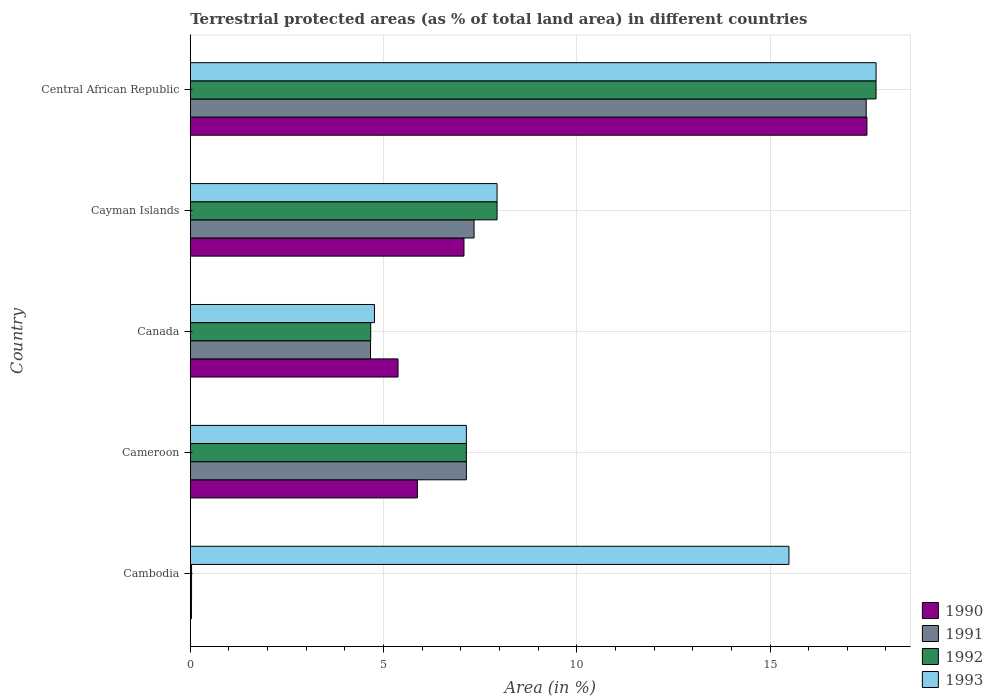How many groups of bars are there?
Ensure brevity in your answer.  5. What is the label of the 2nd group of bars from the top?
Provide a succinct answer. Cayman Islands. In how many cases, is the number of bars for a given country not equal to the number of legend labels?
Your answer should be compact. 0. What is the percentage of terrestrial protected land in 1993 in Cambodia?
Offer a terse response. 15.49. Across all countries, what is the maximum percentage of terrestrial protected land in 1993?
Keep it short and to the point. 17.74. Across all countries, what is the minimum percentage of terrestrial protected land in 1993?
Provide a short and direct response. 4.77. In which country was the percentage of terrestrial protected land in 1990 maximum?
Provide a short and direct response. Central African Republic. In which country was the percentage of terrestrial protected land in 1990 minimum?
Give a very brief answer. Cambodia. What is the total percentage of terrestrial protected land in 1993 in the graph?
Your answer should be very brief. 53.08. What is the difference between the percentage of terrestrial protected land in 1990 in Cameroon and that in Central African Republic?
Offer a very short reply. -11.63. What is the difference between the percentage of terrestrial protected land in 1991 in Central African Republic and the percentage of terrestrial protected land in 1992 in Canada?
Your answer should be very brief. 12.82. What is the average percentage of terrestrial protected land in 1990 per country?
Ensure brevity in your answer.  7.17. What is the difference between the percentage of terrestrial protected land in 1993 and percentage of terrestrial protected land in 1992 in Canada?
Offer a very short reply. 0.1. What is the ratio of the percentage of terrestrial protected land in 1990 in Cambodia to that in Cayman Islands?
Give a very brief answer. 0. Is the percentage of terrestrial protected land in 1991 in Cambodia less than that in Canada?
Give a very brief answer. Yes. What is the difference between the highest and the second highest percentage of terrestrial protected land in 1990?
Provide a short and direct response. 10.43. What is the difference between the highest and the lowest percentage of terrestrial protected land in 1992?
Your answer should be compact. 17.71. Is it the case that in every country, the sum of the percentage of terrestrial protected land in 1993 and percentage of terrestrial protected land in 1992 is greater than the sum of percentage of terrestrial protected land in 1991 and percentage of terrestrial protected land in 1990?
Give a very brief answer. Yes. What does the 1st bar from the top in Canada represents?
Keep it short and to the point. 1993. What does the 3rd bar from the bottom in Cameroon represents?
Your response must be concise. 1992. Are all the bars in the graph horizontal?
Your answer should be compact. Yes. How many countries are there in the graph?
Give a very brief answer. 5. What is the difference between two consecutive major ticks on the X-axis?
Provide a short and direct response. 5. Are the values on the major ticks of X-axis written in scientific E-notation?
Your response must be concise. No. Does the graph contain grids?
Your response must be concise. Yes. Where does the legend appear in the graph?
Your answer should be compact. Bottom right. What is the title of the graph?
Provide a succinct answer. Terrestrial protected areas (as % of total land area) in different countries. Does "1969" appear as one of the legend labels in the graph?
Provide a succinct answer. No. What is the label or title of the X-axis?
Provide a short and direct response. Area (in %). What is the Area (in %) of 1990 in Cambodia?
Keep it short and to the point. 0.03. What is the Area (in %) of 1991 in Cambodia?
Keep it short and to the point. 0.03. What is the Area (in %) of 1992 in Cambodia?
Ensure brevity in your answer.  0.03. What is the Area (in %) in 1993 in Cambodia?
Make the answer very short. 15.49. What is the Area (in %) of 1990 in Cameroon?
Keep it short and to the point. 5.88. What is the Area (in %) in 1991 in Cameroon?
Give a very brief answer. 7.14. What is the Area (in %) in 1992 in Cameroon?
Give a very brief answer. 7.14. What is the Area (in %) of 1993 in Cameroon?
Make the answer very short. 7.14. What is the Area (in %) of 1990 in Canada?
Your answer should be compact. 5.37. What is the Area (in %) of 1991 in Canada?
Your answer should be compact. 4.66. What is the Area (in %) in 1992 in Canada?
Ensure brevity in your answer.  4.67. What is the Area (in %) of 1993 in Canada?
Offer a very short reply. 4.77. What is the Area (in %) in 1990 in Cayman Islands?
Make the answer very short. 7.08. What is the Area (in %) of 1991 in Cayman Islands?
Your response must be concise. 7.34. What is the Area (in %) of 1992 in Cayman Islands?
Give a very brief answer. 7.94. What is the Area (in %) in 1993 in Cayman Islands?
Offer a terse response. 7.94. What is the Area (in %) in 1990 in Central African Republic?
Provide a succinct answer. 17.51. What is the Area (in %) of 1991 in Central African Republic?
Give a very brief answer. 17.49. What is the Area (in %) in 1992 in Central African Republic?
Provide a short and direct response. 17.74. What is the Area (in %) in 1993 in Central African Republic?
Make the answer very short. 17.74. Across all countries, what is the maximum Area (in %) of 1990?
Offer a terse response. 17.51. Across all countries, what is the maximum Area (in %) of 1991?
Provide a succinct answer. 17.49. Across all countries, what is the maximum Area (in %) of 1992?
Offer a very short reply. 17.74. Across all countries, what is the maximum Area (in %) in 1993?
Ensure brevity in your answer.  17.74. Across all countries, what is the minimum Area (in %) of 1990?
Give a very brief answer. 0.03. Across all countries, what is the minimum Area (in %) in 1991?
Your answer should be very brief. 0.03. Across all countries, what is the minimum Area (in %) of 1992?
Offer a very short reply. 0.03. Across all countries, what is the minimum Area (in %) of 1993?
Your answer should be very brief. 4.77. What is the total Area (in %) in 1990 in the graph?
Keep it short and to the point. 35.87. What is the total Area (in %) of 1991 in the graph?
Keep it short and to the point. 36.67. What is the total Area (in %) of 1992 in the graph?
Offer a very short reply. 37.53. What is the total Area (in %) in 1993 in the graph?
Your answer should be compact. 53.08. What is the difference between the Area (in %) in 1990 in Cambodia and that in Cameroon?
Keep it short and to the point. -5.85. What is the difference between the Area (in %) in 1991 in Cambodia and that in Cameroon?
Provide a short and direct response. -7.11. What is the difference between the Area (in %) of 1992 in Cambodia and that in Cameroon?
Your response must be concise. -7.11. What is the difference between the Area (in %) of 1993 in Cambodia and that in Cameroon?
Offer a terse response. 8.35. What is the difference between the Area (in %) of 1990 in Cambodia and that in Canada?
Your response must be concise. -5.35. What is the difference between the Area (in %) in 1991 in Cambodia and that in Canada?
Your answer should be compact. -4.63. What is the difference between the Area (in %) of 1992 in Cambodia and that in Canada?
Provide a succinct answer. -4.64. What is the difference between the Area (in %) of 1993 in Cambodia and that in Canada?
Offer a terse response. 10.72. What is the difference between the Area (in %) of 1990 in Cambodia and that in Cayman Islands?
Give a very brief answer. -7.05. What is the difference between the Area (in %) in 1991 in Cambodia and that in Cayman Islands?
Your response must be concise. -7.31. What is the difference between the Area (in %) of 1992 in Cambodia and that in Cayman Islands?
Your response must be concise. -7.9. What is the difference between the Area (in %) in 1993 in Cambodia and that in Cayman Islands?
Keep it short and to the point. 7.55. What is the difference between the Area (in %) of 1990 in Cambodia and that in Central African Republic?
Give a very brief answer. -17.48. What is the difference between the Area (in %) in 1991 in Cambodia and that in Central African Republic?
Give a very brief answer. -17.46. What is the difference between the Area (in %) of 1992 in Cambodia and that in Central African Republic?
Give a very brief answer. -17.71. What is the difference between the Area (in %) of 1993 in Cambodia and that in Central African Republic?
Provide a short and direct response. -2.25. What is the difference between the Area (in %) in 1990 in Cameroon and that in Canada?
Your answer should be compact. 0.5. What is the difference between the Area (in %) in 1991 in Cameroon and that in Canada?
Make the answer very short. 2.48. What is the difference between the Area (in %) in 1992 in Cameroon and that in Canada?
Your response must be concise. 2.48. What is the difference between the Area (in %) in 1993 in Cameroon and that in Canada?
Your response must be concise. 2.38. What is the difference between the Area (in %) of 1990 in Cameroon and that in Cayman Islands?
Offer a terse response. -1.21. What is the difference between the Area (in %) in 1991 in Cameroon and that in Cayman Islands?
Ensure brevity in your answer.  -0.2. What is the difference between the Area (in %) in 1992 in Cameroon and that in Cayman Islands?
Provide a succinct answer. -0.79. What is the difference between the Area (in %) in 1993 in Cameroon and that in Cayman Islands?
Give a very brief answer. -0.79. What is the difference between the Area (in %) of 1990 in Cameroon and that in Central African Republic?
Provide a short and direct response. -11.63. What is the difference between the Area (in %) in 1991 in Cameroon and that in Central African Republic?
Keep it short and to the point. -10.35. What is the difference between the Area (in %) of 1992 in Cameroon and that in Central African Republic?
Your response must be concise. -10.6. What is the difference between the Area (in %) of 1993 in Cameroon and that in Central African Republic?
Provide a succinct answer. -10.6. What is the difference between the Area (in %) of 1990 in Canada and that in Cayman Islands?
Make the answer very short. -1.71. What is the difference between the Area (in %) of 1991 in Canada and that in Cayman Islands?
Provide a short and direct response. -2.68. What is the difference between the Area (in %) of 1992 in Canada and that in Cayman Islands?
Your answer should be very brief. -3.27. What is the difference between the Area (in %) of 1993 in Canada and that in Cayman Islands?
Your answer should be very brief. -3.17. What is the difference between the Area (in %) in 1990 in Canada and that in Central African Republic?
Your answer should be compact. -12.13. What is the difference between the Area (in %) of 1991 in Canada and that in Central African Republic?
Ensure brevity in your answer.  -12.83. What is the difference between the Area (in %) in 1992 in Canada and that in Central African Republic?
Your response must be concise. -13.07. What is the difference between the Area (in %) in 1993 in Canada and that in Central African Republic?
Provide a succinct answer. -12.98. What is the difference between the Area (in %) in 1990 in Cayman Islands and that in Central African Republic?
Offer a terse response. -10.43. What is the difference between the Area (in %) of 1991 in Cayman Islands and that in Central African Republic?
Your response must be concise. -10.15. What is the difference between the Area (in %) of 1992 in Cayman Islands and that in Central African Republic?
Your answer should be very brief. -9.81. What is the difference between the Area (in %) of 1993 in Cayman Islands and that in Central African Republic?
Your response must be concise. -9.81. What is the difference between the Area (in %) of 1990 in Cambodia and the Area (in %) of 1991 in Cameroon?
Your answer should be very brief. -7.11. What is the difference between the Area (in %) in 1990 in Cambodia and the Area (in %) in 1992 in Cameroon?
Your answer should be very brief. -7.11. What is the difference between the Area (in %) in 1990 in Cambodia and the Area (in %) in 1993 in Cameroon?
Offer a very short reply. -7.11. What is the difference between the Area (in %) of 1991 in Cambodia and the Area (in %) of 1992 in Cameroon?
Give a very brief answer. -7.11. What is the difference between the Area (in %) in 1991 in Cambodia and the Area (in %) in 1993 in Cameroon?
Make the answer very short. -7.11. What is the difference between the Area (in %) in 1992 in Cambodia and the Area (in %) in 1993 in Cameroon?
Provide a succinct answer. -7.11. What is the difference between the Area (in %) in 1990 in Cambodia and the Area (in %) in 1991 in Canada?
Make the answer very short. -4.63. What is the difference between the Area (in %) in 1990 in Cambodia and the Area (in %) in 1992 in Canada?
Your answer should be compact. -4.64. What is the difference between the Area (in %) of 1990 in Cambodia and the Area (in %) of 1993 in Canada?
Provide a succinct answer. -4.74. What is the difference between the Area (in %) in 1991 in Cambodia and the Area (in %) in 1992 in Canada?
Ensure brevity in your answer.  -4.64. What is the difference between the Area (in %) in 1991 in Cambodia and the Area (in %) in 1993 in Canada?
Your response must be concise. -4.73. What is the difference between the Area (in %) of 1992 in Cambodia and the Area (in %) of 1993 in Canada?
Your response must be concise. -4.73. What is the difference between the Area (in %) of 1990 in Cambodia and the Area (in %) of 1991 in Cayman Islands?
Make the answer very short. -7.31. What is the difference between the Area (in %) in 1990 in Cambodia and the Area (in %) in 1992 in Cayman Islands?
Make the answer very short. -7.91. What is the difference between the Area (in %) of 1990 in Cambodia and the Area (in %) of 1993 in Cayman Islands?
Offer a very short reply. -7.91. What is the difference between the Area (in %) of 1991 in Cambodia and the Area (in %) of 1992 in Cayman Islands?
Ensure brevity in your answer.  -7.9. What is the difference between the Area (in %) in 1991 in Cambodia and the Area (in %) in 1993 in Cayman Islands?
Make the answer very short. -7.9. What is the difference between the Area (in %) in 1992 in Cambodia and the Area (in %) in 1993 in Cayman Islands?
Provide a succinct answer. -7.9. What is the difference between the Area (in %) of 1990 in Cambodia and the Area (in %) of 1991 in Central African Republic?
Ensure brevity in your answer.  -17.46. What is the difference between the Area (in %) in 1990 in Cambodia and the Area (in %) in 1992 in Central African Republic?
Keep it short and to the point. -17.71. What is the difference between the Area (in %) in 1990 in Cambodia and the Area (in %) in 1993 in Central African Republic?
Your response must be concise. -17.71. What is the difference between the Area (in %) of 1991 in Cambodia and the Area (in %) of 1992 in Central African Republic?
Keep it short and to the point. -17.71. What is the difference between the Area (in %) of 1991 in Cambodia and the Area (in %) of 1993 in Central African Republic?
Your response must be concise. -17.71. What is the difference between the Area (in %) in 1992 in Cambodia and the Area (in %) in 1993 in Central African Republic?
Provide a succinct answer. -17.71. What is the difference between the Area (in %) in 1990 in Cameroon and the Area (in %) in 1991 in Canada?
Provide a short and direct response. 1.21. What is the difference between the Area (in %) in 1990 in Cameroon and the Area (in %) in 1992 in Canada?
Ensure brevity in your answer.  1.21. What is the difference between the Area (in %) of 1990 in Cameroon and the Area (in %) of 1993 in Canada?
Give a very brief answer. 1.11. What is the difference between the Area (in %) of 1991 in Cameroon and the Area (in %) of 1992 in Canada?
Offer a very short reply. 2.48. What is the difference between the Area (in %) of 1991 in Cameroon and the Area (in %) of 1993 in Canada?
Offer a terse response. 2.38. What is the difference between the Area (in %) of 1992 in Cameroon and the Area (in %) of 1993 in Canada?
Your response must be concise. 2.38. What is the difference between the Area (in %) in 1990 in Cameroon and the Area (in %) in 1991 in Cayman Islands?
Keep it short and to the point. -1.47. What is the difference between the Area (in %) of 1990 in Cameroon and the Area (in %) of 1992 in Cayman Islands?
Your answer should be compact. -2.06. What is the difference between the Area (in %) in 1990 in Cameroon and the Area (in %) in 1993 in Cayman Islands?
Provide a succinct answer. -2.06. What is the difference between the Area (in %) in 1991 in Cameroon and the Area (in %) in 1992 in Cayman Islands?
Provide a short and direct response. -0.79. What is the difference between the Area (in %) of 1991 in Cameroon and the Area (in %) of 1993 in Cayman Islands?
Offer a terse response. -0.79. What is the difference between the Area (in %) in 1992 in Cameroon and the Area (in %) in 1993 in Cayman Islands?
Make the answer very short. -0.79. What is the difference between the Area (in %) of 1990 in Cameroon and the Area (in %) of 1991 in Central African Republic?
Offer a very short reply. -11.61. What is the difference between the Area (in %) of 1990 in Cameroon and the Area (in %) of 1992 in Central African Republic?
Provide a succinct answer. -11.87. What is the difference between the Area (in %) in 1990 in Cameroon and the Area (in %) in 1993 in Central African Republic?
Your answer should be very brief. -11.87. What is the difference between the Area (in %) of 1991 in Cameroon and the Area (in %) of 1992 in Central African Republic?
Keep it short and to the point. -10.6. What is the difference between the Area (in %) in 1991 in Cameroon and the Area (in %) in 1993 in Central African Republic?
Offer a very short reply. -10.6. What is the difference between the Area (in %) in 1992 in Cameroon and the Area (in %) in 1993 in Central African Republic?
Provide a short and direct response. -10.6. What is the difference between the Area (in %) in 1990 in Canada and the Area (in %) in 1991 in Cayman Islands?
Offer a very short reply. -1.97. What is the difference between the Area (in %) in 1990 in Canada and the Area (in %) in 1992 in Cayman Islands?
Provide a succinct answer. -2.56. What is the difference between the Area (in %) in 1990 in Canada and the Area (in %) in 1993 in Cayman Islands?
Make the answer very short. -2.56. What is the difference between the Area (in %) in 1991 in Canada and the Area (in %) in 1992 in Cayman Islands?
Give a very brief answer. -3.27. What is the difference between the Area (in %) in 1991 in Canada and the Area (in %) in 1993 in Cayman Islands?
Ensure brevity in your answer.  -3.27. What is the difference between the Area (in %) in 1992 in Canada and the Area (in %) in 1993 in Cayman Islands?
Keep it short and to the point. -3.27. What is the difference between the Area (in %) of 1990 in Canada and the Area (in %) of 1991 in Central African Republic?
Keep it short and to the point. -12.11. What is the difference between the Area (in %) in 1990 in Canada and the Area (in %) in 1992 in Central African Republic?
Make the answer very short. -12.37. What is the difference between the Area (in %) of 1990 in Canada and the Area (in %) of 1993 in Central African Republic?
Provide a short and direct response. -12.37. What is the difference between the Area (in %) in 1991 in Canada and the Area (in %) in 1992 in Central African Republic?
Offer a terse response. -13.08. What is the difference between the Area (in %) of 1991 in Canada and the Area (in %) of 1993 in Central African Republic?
Offer a terse response. -13.08. What is the difference between the Area (in %) in 1992 in Canada and the Area (in %) in 1993 in Central African Republic?
Offer a very short reply. -13.08. What is the difference between the Area (in %) in 1990 in Cayman Islands and the Area (in %) in 1991 in Central African Republic?
Your answer should be very brief. -10.41. What is the difference between the Area (in %) of 1990 in Cayman Islands and the Area (in %) of 1992 in Central African Republic?
Your response must be concise. -10.66. What is the difference between the Area (in %) in 1990 in Cayman Islands and the Area (in %) in 1993 in Central African Republic?
Keep it short and to the point. -10.66. What is the difference between the Area (in %) in 1991 in Cayman Islands and the Area (in %) in 1992 in Central African Republic?
Provide a succinct answer. -10.4. What is the difference between the Area (in %) of 1991 in Cayman Islands and the Area (in %) of 1993 in Central African Republic?
Provide a succinct answer. -10.4. What is the difference between the Area (in %) in 1992 in Cayman Islands and the Area (in %) in 1993 in Central African Republic?
Offer a very short reply. -9.81. What is the average Area (in %) of 1990 per country?
Offer a very short reply. 7.17. What is the average Area (in %) of 1991 per country?
Your answer should be compact. 7.33. What is the average Area (in %) in 1992 per country?
Keep it short and to the point. 7.51. What is the average Area (in %) of 1993 per country?
Keep it short and to the point. 10.62. What is the difference between the Area (in %) of 1990 and Area (in %) of 1991 in Cambodia?
Keep it short and to the point. -0. What is the difference between the Area (in %) of 1990 and Area (in %) of 1992 in Cambodia?
Your answer should be very brief. -0. What is the difference between the Area (in %) in 1990 and Area (in %) in 1993 in Cambodia?
Your answer should be compact. -15.46. What is the difference between the Area (in %) of 1991 and Area (in %) of 1992 in Cambodia?
Give a very brief answer. 0. What is the difference between the Area (in %) in 1991 and Area (in %) in 1993 in Cambodia?
Provide a short and direct response. -15.46. What is the difference between the Area (in %) of 1992 and Area (in %) of 1993 in Cambodia?
Keep it short and to the point. -15.46. What is the difference between the Area (in %) in 1990 and Area (in %) in 1991 in Cameroon?
Your answer should be very brief. -1.27. What is the difference between the Area (in %) of 1990 and Area (in %) of 1992 in Cameroon?
Give a very brief answer. -1.27. What is the difference between the Area (in %) of 1990 and Area (in %) of 1993 in Cameroon?
Provide a short and direct response. -1.27. What is the difference between the Area (in %) of 1991 and Area (in %) of 1992 in Cameroon?
Provide a short and direct response. 0. What is the difference between the Area (in %) in 1990 and Area (in %) in 1991 in Canada?
Make the answer very short. 0.71. What is the difference between the Area (in %) in 1990 and Area (in %) in 1992 in Canada?
Provide a short and direct response. 0.71. What is the difference between the Area (in %) in 1990 and Area (in %) in 1993 in Canada?
Your answer should be compact. 0.61. What is the difference between the Area (in %) in 1991 and Area (in %) in 1992 in Canada?
Ensure brevity in your answer.  -0. What is the difference between the Area (in %) of 1991 and Area (in %) of 1993 in Canada?
Keep it short and to the point. -0.1. What is the difference between the Area (in %) in 1992 and Area (in %) in 1993 in Canada?
Your answer should be compact. -0.1. What is the difference between the Area (in %) of 1990 and Area (in %) of 1991 in Cayman Islands?
Offer a terse response. -0.26. What is the difference between the Area (in %) of 1990 and Area (in %) of 1992 in Cayman Islands?
Offer a very short reply. -0.86. What is the difference between the Area (in %) of 1990 and Area (in %) of 1993 in Cayman Islands?
Your answer should be very brief. -0.86. What is the difference between the Area (in %) of 1991 and Area (in %) of 1992 in Cayman Islands?
Provide a short and direct response. -0.6. What is the difference between the Area (in %) of 1991 and Area (in %) of 1993 in Cayman Islands?
Your answer should be very brief. -0.6. What is the difference between the Area (in %) in 1992 and Area (in %) in 1993 in Cayman Islands?
Keep it short and to the point. 0. What is the difference between the Area (in %) in 1990 and Area (in %) in 1991 in Central African Republic?
Ensure brevity in your answer.  0.02. What is the difference between the Area (in %) in 1990 and Area (in %) in 1992 in Central African Republic?
Your answer should be very brief. -0.24. What is the difference between the Area (in %) in 1990 and Area (in %) in 1993 in Central African Republic?
Make the answer very short. -0.24. What is the difference between the Area (in %) in 1991 and Area (in %) in 1992 in Central African Republic?
Your response must be concise. -0.25. What is the difference between the Area (in %) of 1991 and Area (in %) of 1993 in Central African Republic?
Keep it short and to the point. -0.26. What is the difference between the Area (in %) in 1992 and Area (in %) in 1993 in Central African Republic?
Your answer should be compact. -0. What is the ratio of the Area (in %) of 1990 in Cambodia to that in Cameroon?
Provide a short and direct response. 0.01. What is the ratio of the Area (in %) in 1991 in Cambodia to that in Cameroon?
Provide a succinct answer. 0. What is the ratio of the Area (in %) of 1992 in Cambodia to that in Cameroon?
Your response must be concise. 0. What is the ratio of the Area (in %) of 1993 in Cambodia to that in Cameroon?
Offer a very short reply. 2.17. What is the ratio of the Area (in %) of 1990 in Cambodia to that in Canada?
Your answer should be very brief. 0.01. What is the ratio of the Area (in %) in 1991 in Cambodia to that in Canada?
Give a very brief answer. 0.01. What is the ratio of the Area (in %) of 1992 in Cambodia to that in Canada?
Offer a very short reply. 0.01. What is the ratio of the Area (in %) in 1993 in Cambodia to that in Canada?
Offer a very short reply. 3.25. What is the ratio of the Area (in %) of 1990 in Cambodia to that in Cayman Islands?
Provide a short and direct response. 0. What is the ratio of the Area (in %) in 1991 in Cambodia to that in Cayman Islands?
Offer a terse response. 0. What is the ratio of the Area (in %) in 1992 in Cambodia to that in Cayman Islands?
Give a very brief answer. 0. What is the ratio of the Area (in %) in 1993 in Cambodia to that in Cayman Islands?
Offer a terse response. 1.95. What is the ratio of the Area (in %) of 1990 in Cambodia to that in Central African Republic?
Make the answer very short. 0. What is the ratio of the Area (in %) in 1991 in Cambodia to that in Central African Republic?
Give a very brief answer. 0. What is the ratio of the Area (in %) in 1992 in Cambodia to that in Central African Republic?
Make the answer very short. 0. What is the ratio of the Area (in %) of 1993 in Cambodia to that in Central African Republic?
Make the answer very short. 0.87. What is the ratio of the Area (in %) of 1990 in Cameroon to that in Canada?
Provide a succinct answer. 1.09. What is the ratio of the Area (in %) in 1991 in Cameroon to that in Canada?
Provide a short and direct response. 1.53. What is the ratio of the Area (in %) in 1992 in Cameroon to that in Canada?
Make the answer very short. 1.53. What is the ratio of the Area (in %) in 1993 in Cameroon to that in Canada?
Your response must be concise. 1.5. What is the ratio of the Area (in %) of 1990 in Cameroon to that in Cayman Islands?
Your answer should be compact. 0.83. What is the ratio of the Area (in %) of 1991 in Cameroon to that in Cayman Islands?
Keep it short and to the point. 0.97. What is the ratio of the Area (in %) in 1992 in Cameroon to that in Cayman Islands?
Your answer should be very brief. 0.9. What is the ratio of the Area (in %) in 1993 in Cameroon to that in Cayman Islands?
Provide a short and direct response. 0.9. What is the ratio of the Area (in %) of 1990 in Cameroon to that in Central African Republic?
Make the answer very short. 0.34. What is the ratio of the Area (in %) of 1991 in Cameroon to that in Central African Republic?
Make the answer very short. 0.41. What is the ratio of the Area (in %) in 1992 in Cameroon to that in Central African Republic?
Provide a short and direct response. 0.4. What is the ratio of the Area (in %) in 1993 in Cameroon to that in Central African Republic?
Your answer should be compact. 0.4. What is the ratio of the Area (in %) of 1990 in Canada to that in Cayman Islands?
Provide a succinct answer. 0.76. What is the ratio of the Area (in %) of 1991 in Canada to that in Cayman Islands?
Make the answer very short. 0.64. What is the ratio of the Area (in %) of 1992 in Canada to that in Cayman Islands?
Provide a short and direct response. 0.59. What is the ratio of the Area (in %) in 1993 in Canada to that in Cayman Islands?
Give a very brief answer. 0.6. What is the ratio of the Area (in %) in 1990 in Canada to that in Central African Republic?
Your answer should be very brief. 0.31. What is the ratio of the Area (in %) in 1991 in Canada to that in Central African Republic?
Offer a terse response. 0.27. What is the ratio of the Area (in %) of 1992 in Canada to that in Central African Republic?
Provide a short and direct response. 0.26. What is the ratio of the Area (in %) of 1993 in Canada to that in Central African Republic?
Provide a short and direct response. 0.27. What is the ratio of the Area (in %) of 1990 in Cayman Islands to that in Central African Republic?
Your answer should be very brief. 0.4. What is the ratio of the Area (in %) in 1991 in Cayman Islands to that in Central African Republic?
Give a very brief answer. 0.42. What is the ratio of the Area (in %) of 1992 in Cayman Islands to that in Central African Republic?
Offer a terse response. 0.45. What is the ratio of the Area (in %) in 1993 in Cayman Islands to that in Central African Republic?
Provide a succinct answer. 0.45. What is the difference between the highest and the second highest Area (in %) of 1990?
Make the answer very short. 10.43. What is the difference between the highest and the second highest Area (in %) in 1991?
Give a very brief answer. 10.15. What is the difference between the highest and the second highest Area (in %) in 1992?
Provide a succinct answer. 9.81. What is the difference between the highest and the second highest Area (in %) in 1993?
Provide a short and direct response. 2.25. What is the difference between the highest and the lowest Area (in %) of 1990?
Give a very brief answer. 17.48. What is the difference between the highest and the lowest Area (in %) in 1991?
Provide a short and direct response. 17.46. What is the difference between the highest and the lowest Area (in %) of 1992?
Provide a succinct answer. 17.71. What is the difference between the highest and the lowest Area (in %) of 1993?
Your answer should be very brief. 12.98. 